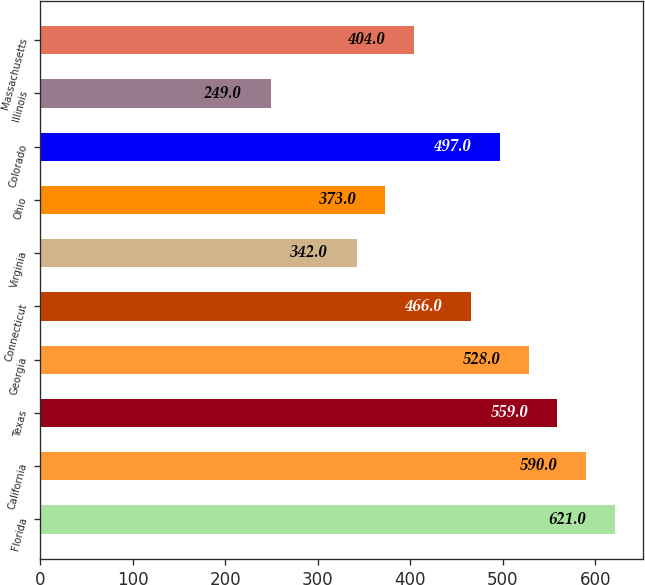Convert chart. <chart><loc_0><loc_0><loc_500><loc_500><bar_chart><fcel>Florida<fcel>California<fcel>Texas<fcel>Georgia<fcel>Connecticut<fcel>Virginia<fcel>Ohio<fcel>Colorado<fcel>Illinois<fcel>Massachusetts<nl><fcel>621<fcel>590<fcel>559<fcel>528<fcel>466<fcel>342<fcel>373<fcel>497<fcel>249<fcel>404<nl></chart> 